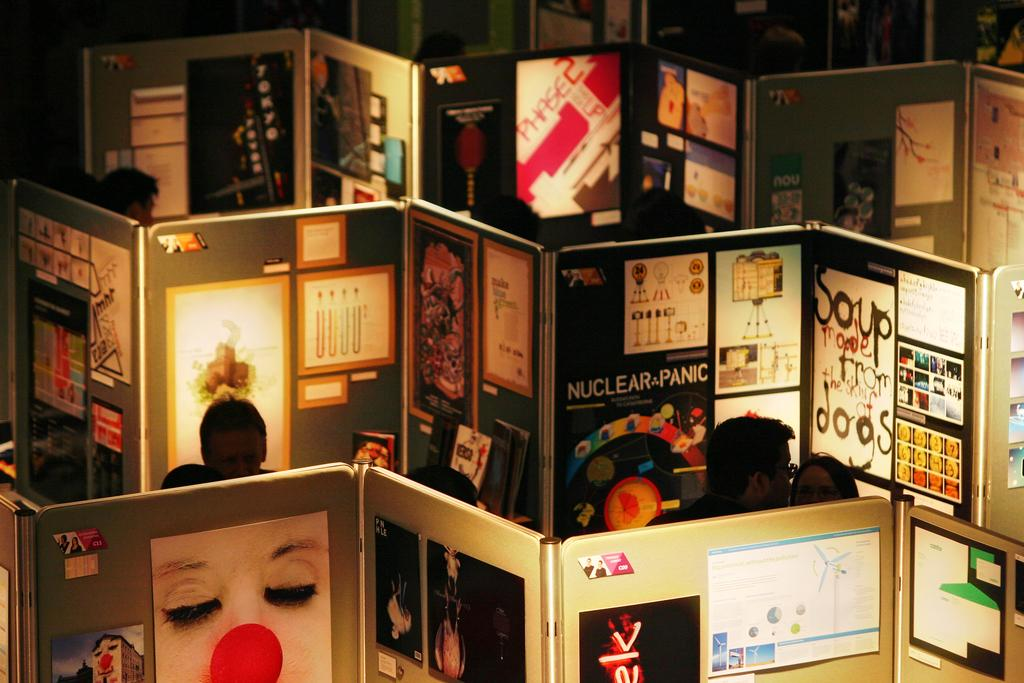What can be seen in the image involving multiple individuals? There is a group of people in the image. What type of structures are present in the image? There are cabins in the image. What objects can be seen that might be related to documentation or communication? Papers are visible in the image. What color is the bird that is perched on the cabin in the image? There is no bird present in the image; only a group of people, cabins, and papers are visible. 